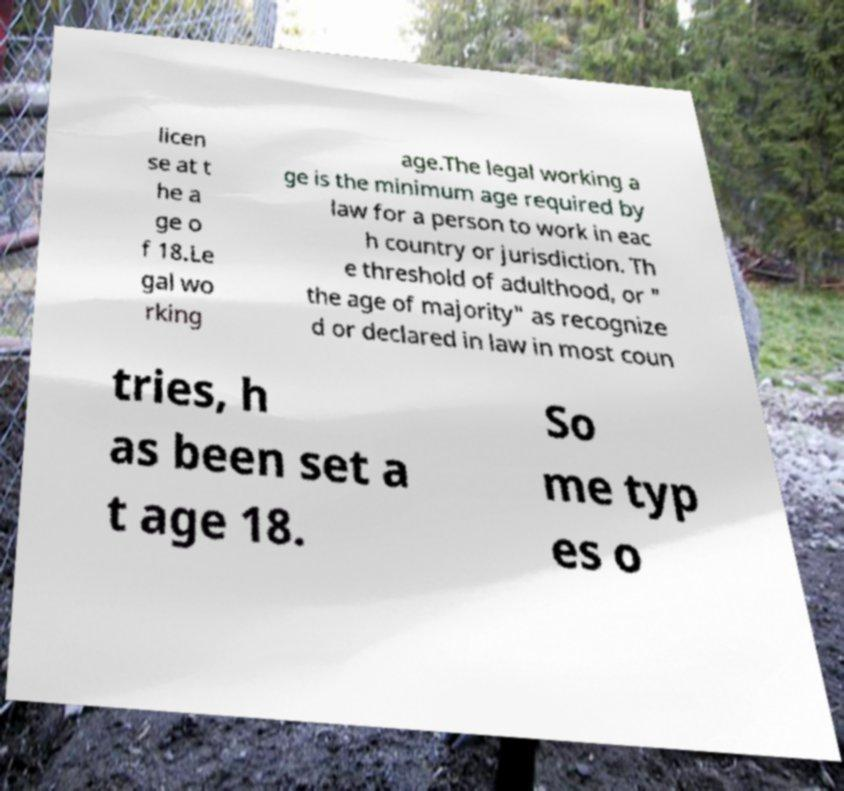Could you assist in decoding the text presented in this image and type it out clearly? licen se at t he a ge o f 18.Le gal wo rking age.The legal working a ge is the minimum age required by law for a person to work in eac h country or jurisdiction. Th e threshold of adulthood, or " the age of majority" as recognize d or declared in law in most coun tries, h as been set a t age 18. So me typ es o 